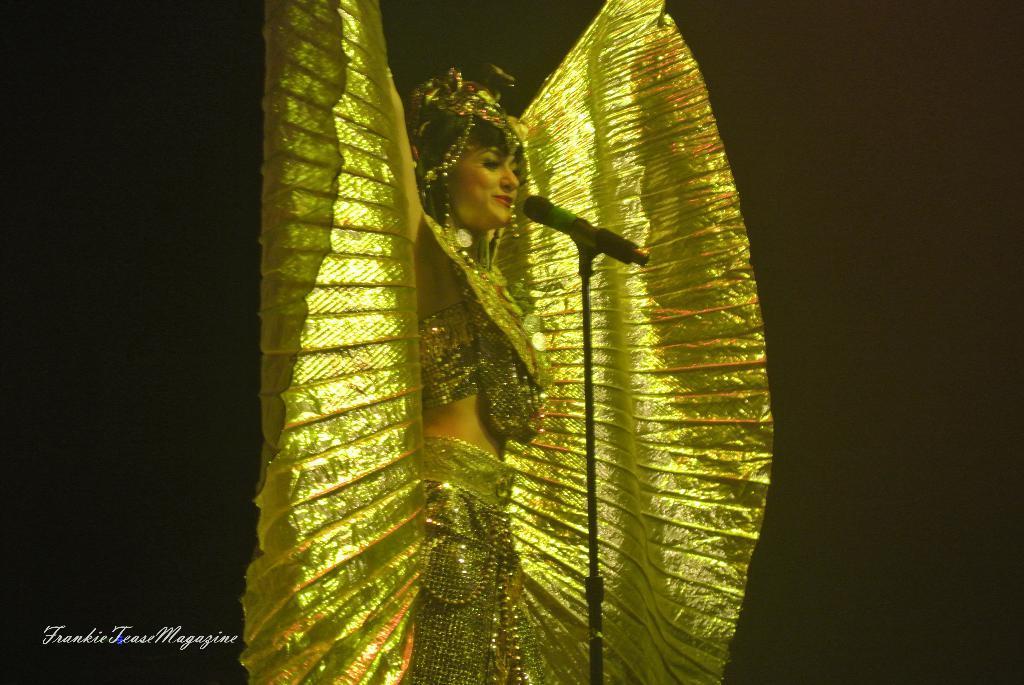How would you summarize this image in a sentence or two? In this image there is a lady wearing a costume. In front of her there is a mike. There is some text at the bottom of the image. 